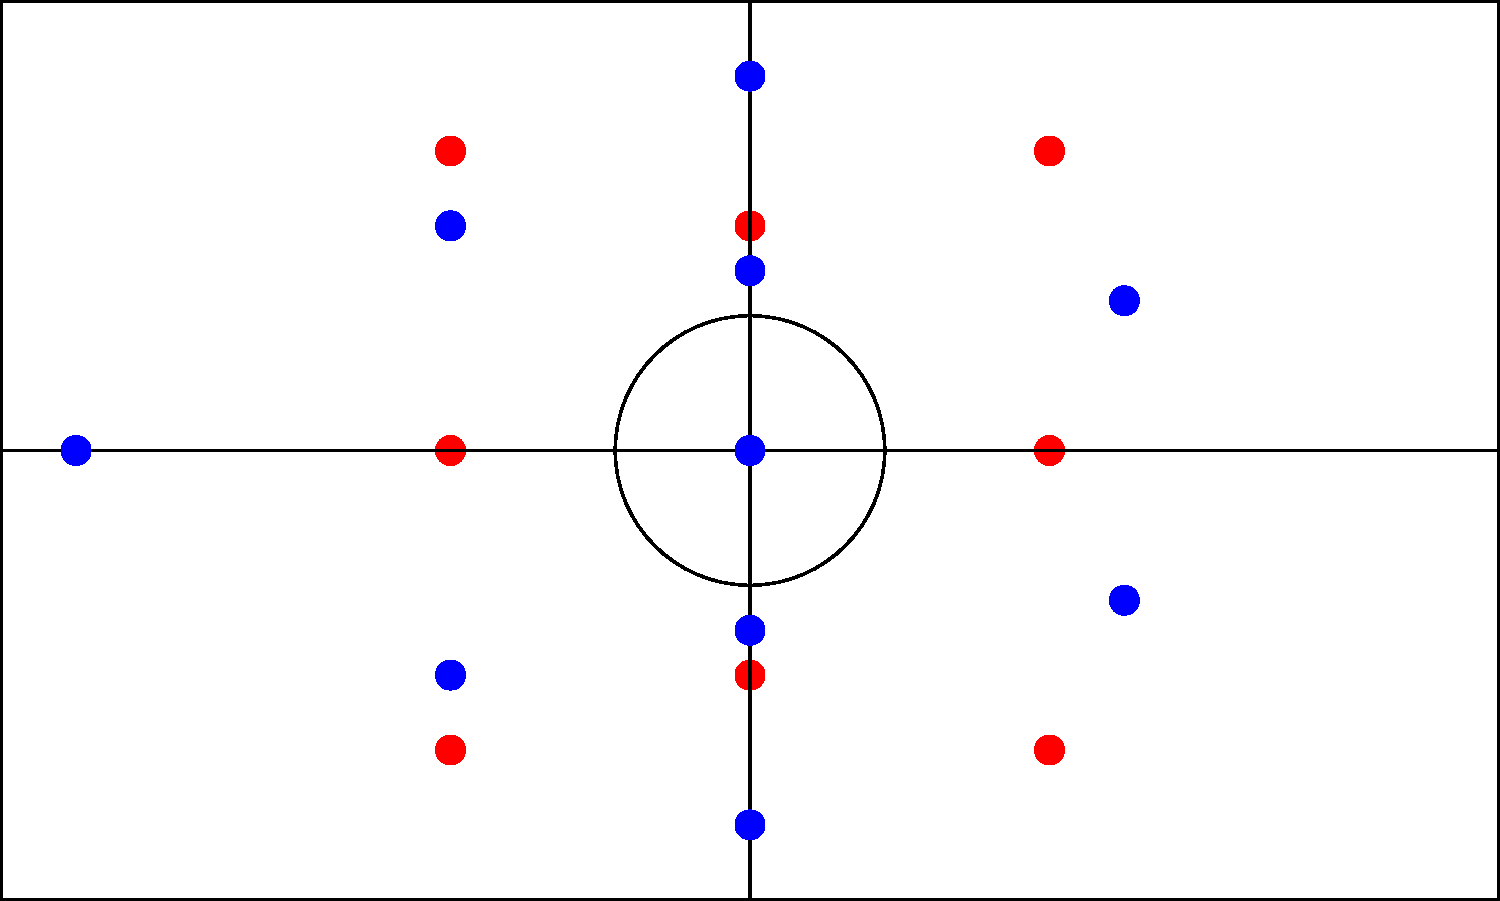Barcelona FC experimented with different formations throughout the 2022-2023 season. The diagram shows two common formations used by the team. Which formation change is represented, and what tactical advantage did it provide to Barcelona FC? To answer this question, let's analyze the two formations shown in the diagram:

1. The left diagram (in red) shows a 4-3-3 formation:
   - 4 defenders in a line
   - 3 midfielders in a line
   - 3 forwards spread across the attack

2. The right diagram (in blue) shows a 3-5-2 formation:
   - 3 defenders at the back
   - 5 midfielders spread across the middle
   - 2 forwards up front

The change represented is from a 4-3-3 to a 3-5-2 formation. This tactical shift provided several advantages to Barcelona FC:

1. Midfield control: The 3-5-2 formation adds an extra midfielder, allowing for better ball possession and control in the middle of the pitch.

2. Wing-back support: In the 3-5-2, the wide midfielders can act as wing-backs, providing both defensive cover and attacking support on the flanks.

3. Defensive solidity: While reducing to three center-backs might seem risky, it often allows for better defensive organization and the ability to play a high defensive line.

4. Attacking flexibility: The two forwards in the 3-5-2 can play closer together, creating more central attacking options and allowing for quick combinations.

5. Adaptability: This formation can easily transition between defensive and attacking phases, making it harder for opponents to predict and counter.

This change likely allowed Barcelona FC to adapt to different opponents and game situations, providing tactical flexibility throughout the season.
Answer: 4-3-3 to 3-5-2; improved midfield control and tactical flexibility 